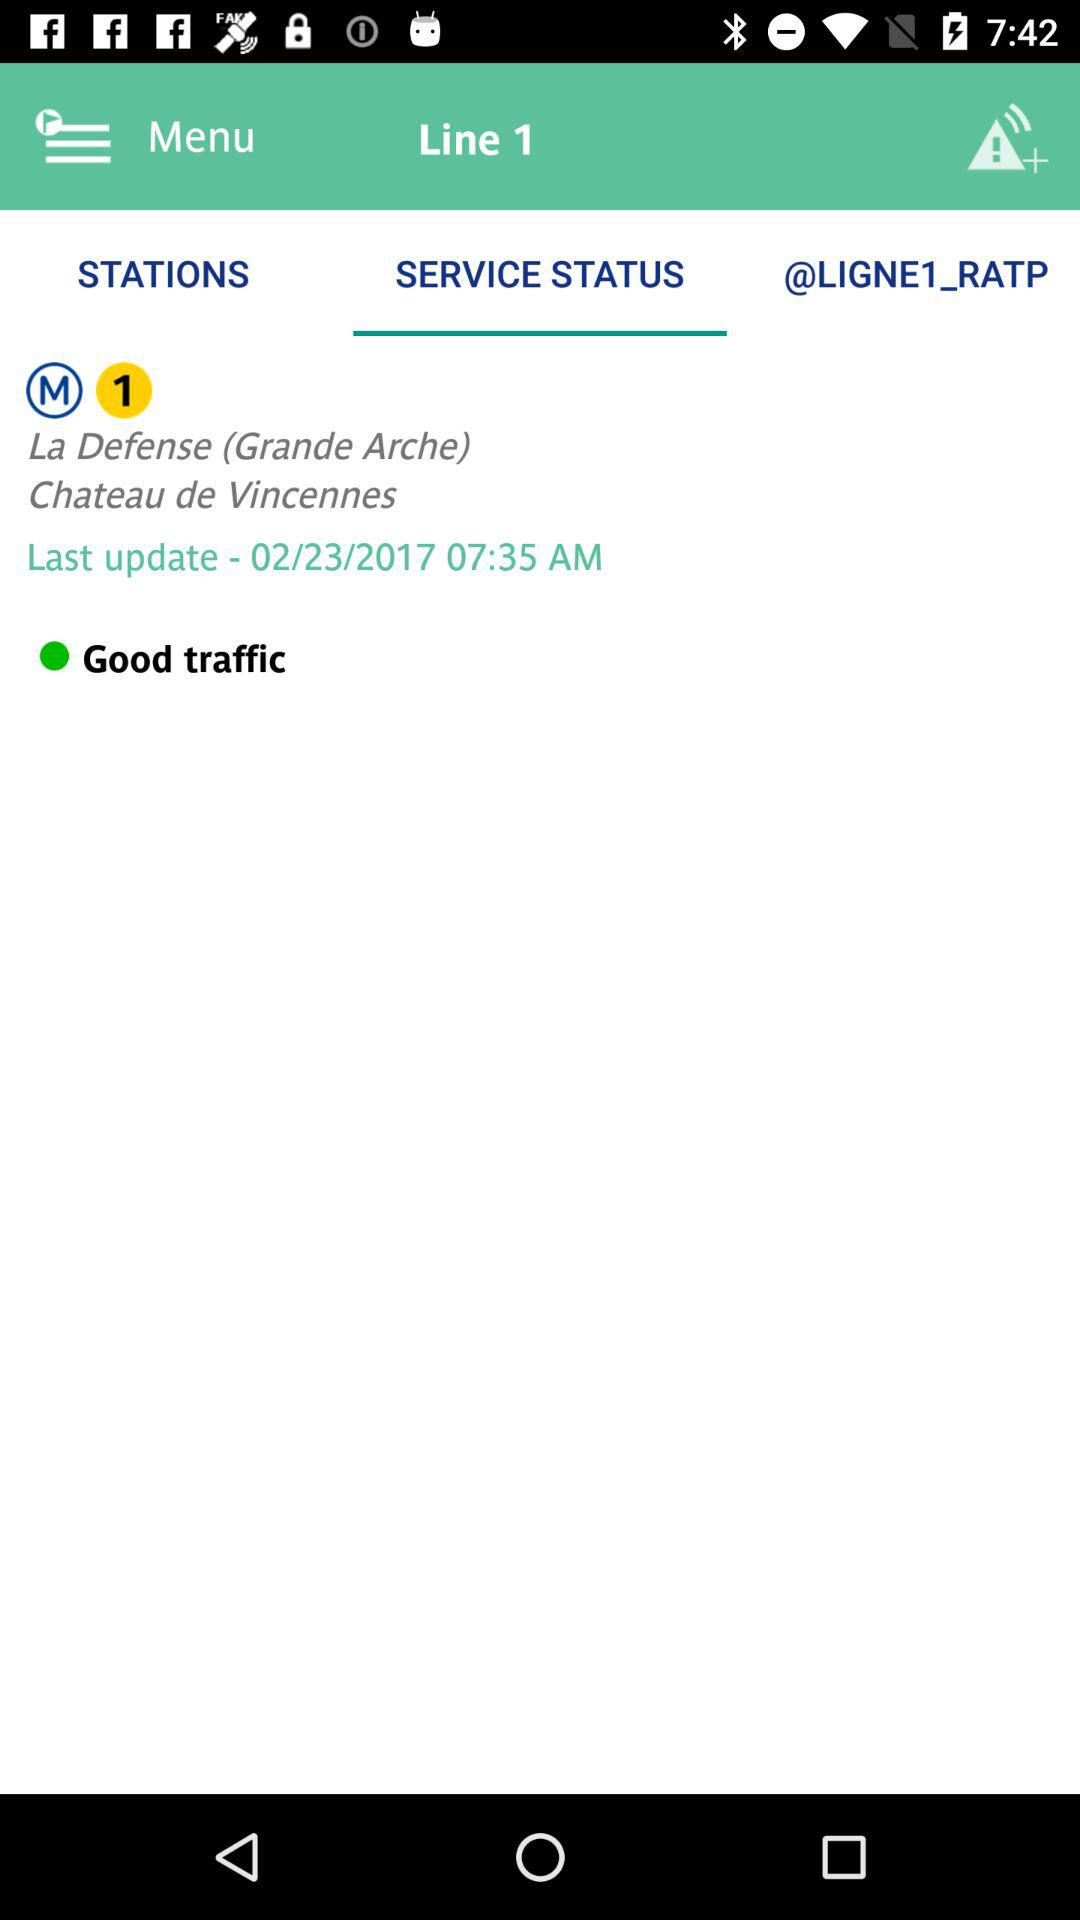When was the last update? The last update was on February 23, 2017 at 7:35 a.m. 